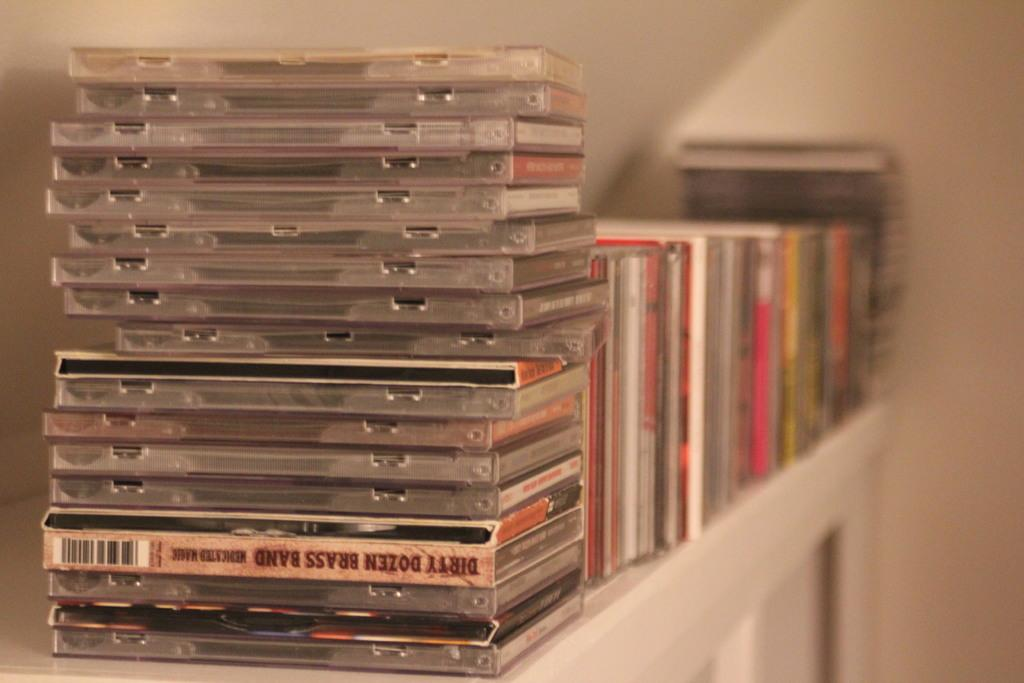<image>
Describe the image concisely. A stack of music cds includes one by the Dirty Dozen Brass Band. 